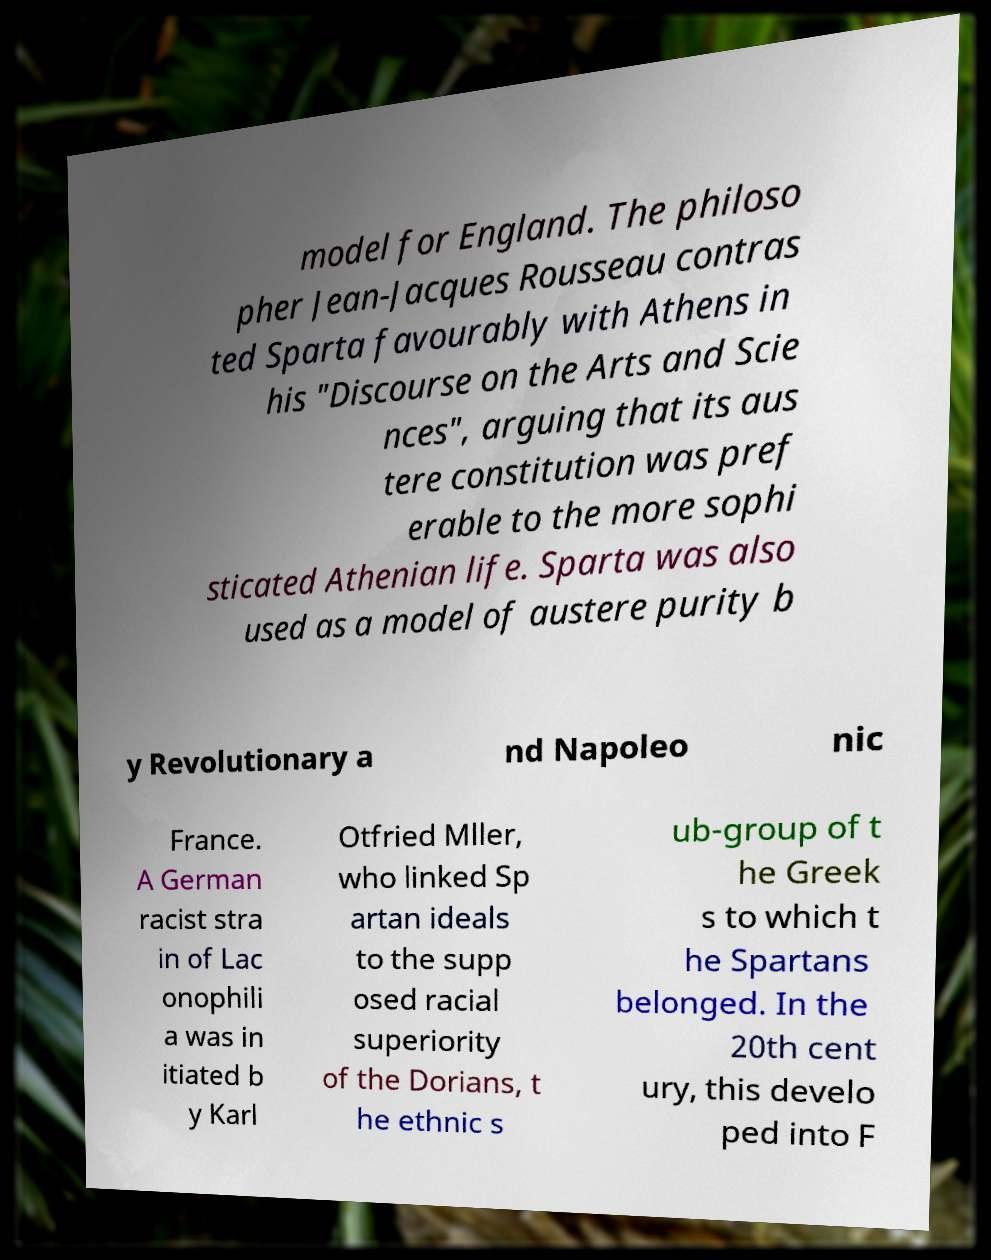Can you read and provide the text displayed in the image?This photo seems to have some interesting text. Can you extract and type it out for me? model for England. The philoso pher Jean-Jacques Rousseau contras ted Sparta favourably with Athens in his "Discourse on the Arts and Scie nces", arguing that its aus tere constitution was pref erable to the more sophi sticated Athenian life. Sparta was also used as a model of austere purity b y Revolutionary a nd Napoleo nic France. A German racist stra in of Lac onophili a was in itiated b y Karl Otfried Mller, who linked Sp artan ideals to the supp osed racial superiority of the Dorians, t he ethnic s ub-group of t he Greek s to which t he Spartans belonged. In the 20th cent ury, this develo ped into F 